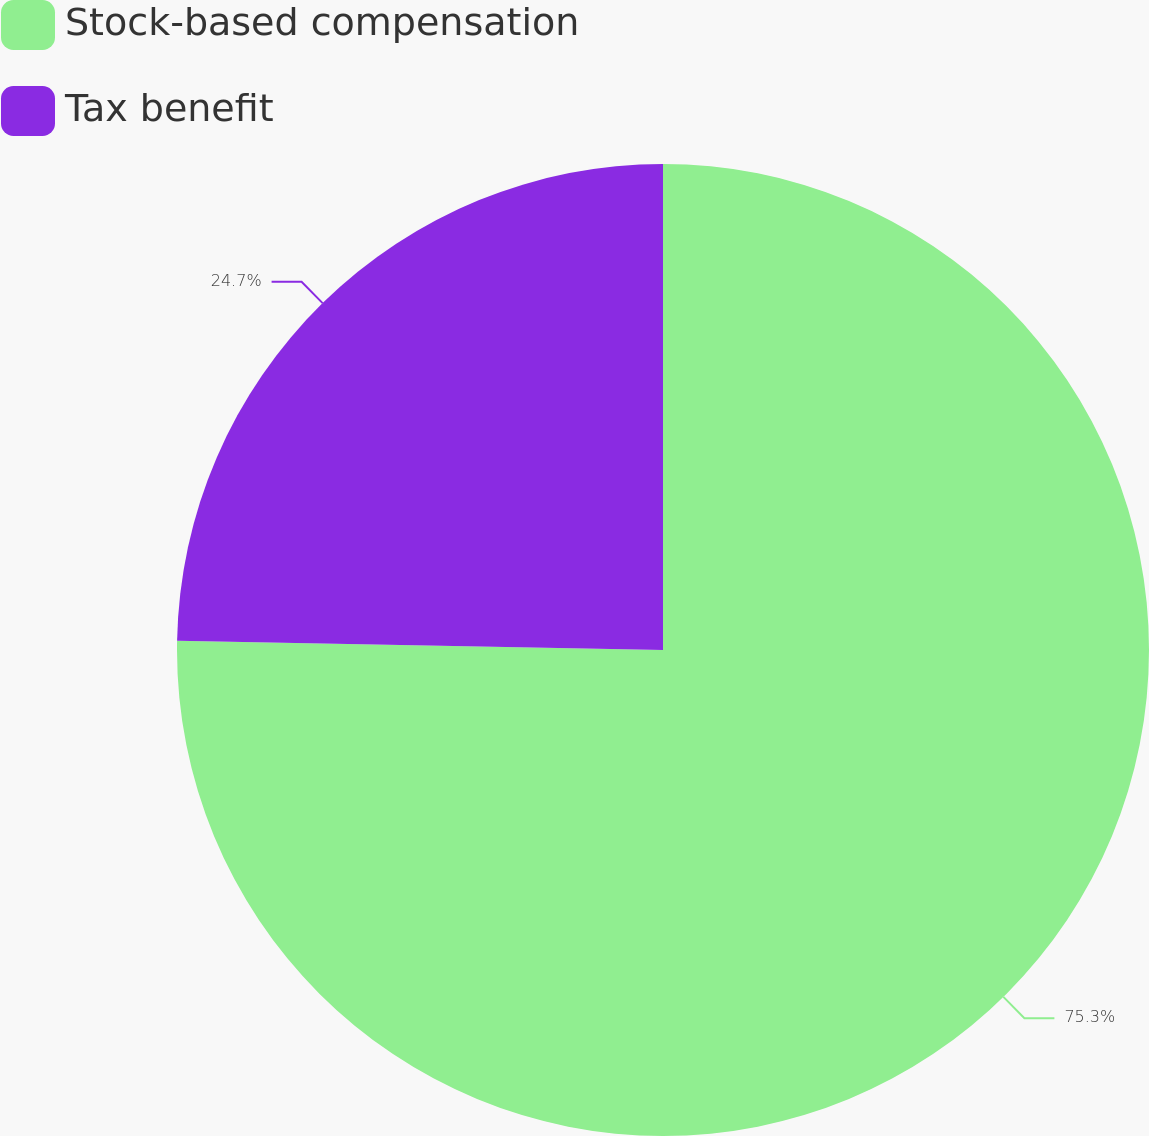Convert chart. <chart><loc_0><loc_0><loc_500><loc_500><pie_chart><fcel>Stock-based compensation<fcel>Tax benefit<nl><fcel>75.3%<fcel>24.7%<nl></chart> 